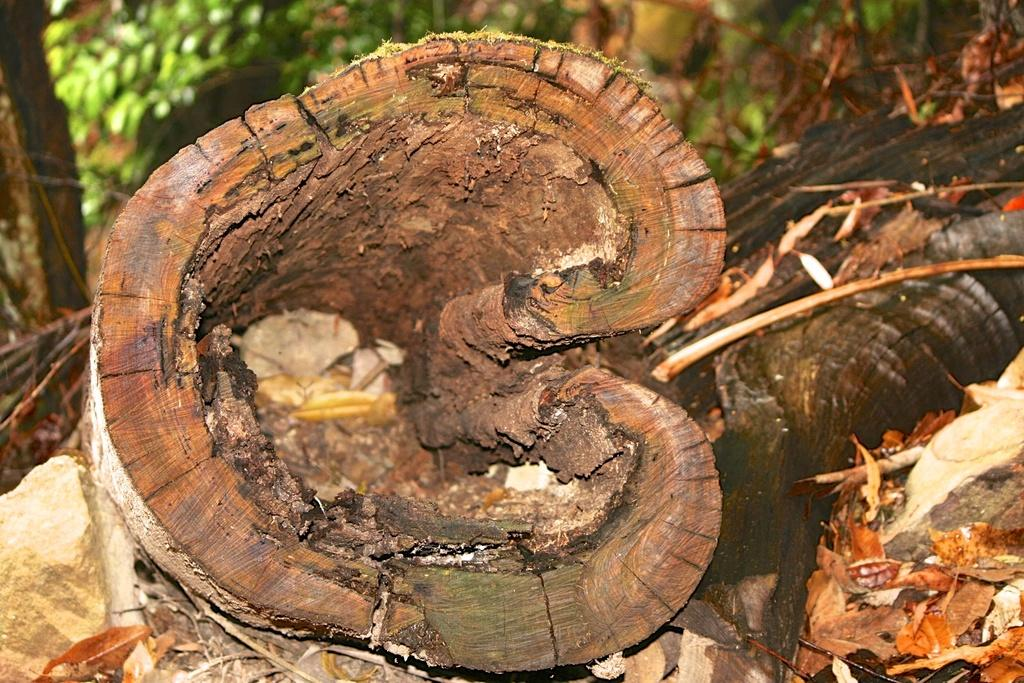What is placed on the ground in the image? There is a wood log placed on the ground. What can be seen in the background of the image? There is a group of trees in the background of the image. How many dolls are sitting on the wood log in the image? There are no dolls present in the image; it only features a wood log placed on the ground and a group of trees in the background. 